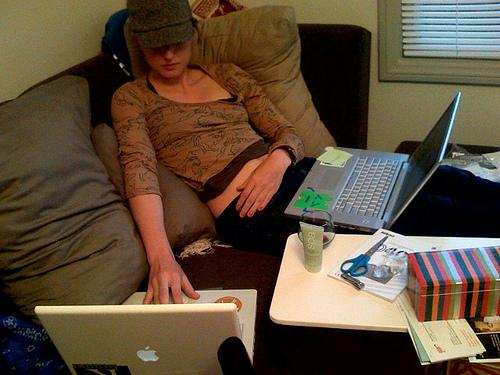Which item might she use on her skin? Please explain your reasoning. tube. The item is full of lotion intended for skin. 